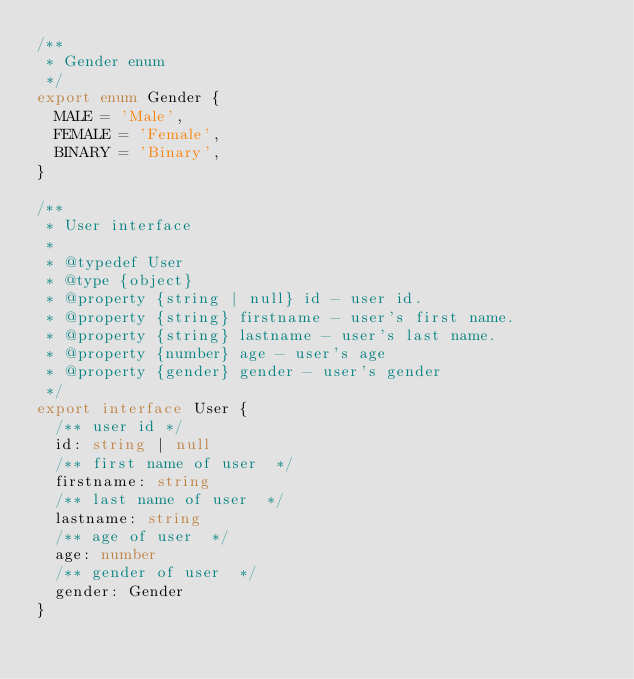Convert code to text. <code><loc_0><loc_0><loc_500><loc_500><_TypeScript_>/**
 * Gender enum
 */
export enum Gender {
  MALE = 'Male',
  FEMALE = 'Female',
  BINARY = 'Binary',
}

/**
 * User interface
 *
 * @typedef User
 * @type {object}
 * @property {string | null} id - user id.
 * @property {string} firstname - user's first name.
 * @property {string} lastname - user's last name.
 * @property {number} age - user's age
 * @property {gender} gender - user's gender
 */
export interface User {
  /** user id */
  id: string | null
  /** first name of user  */
  firstname: string
  /** last name of user  */
  lastname: string
  /** age of user  */
  age: number
  /** gender of user  */
  gender: Gender
}
</code> 